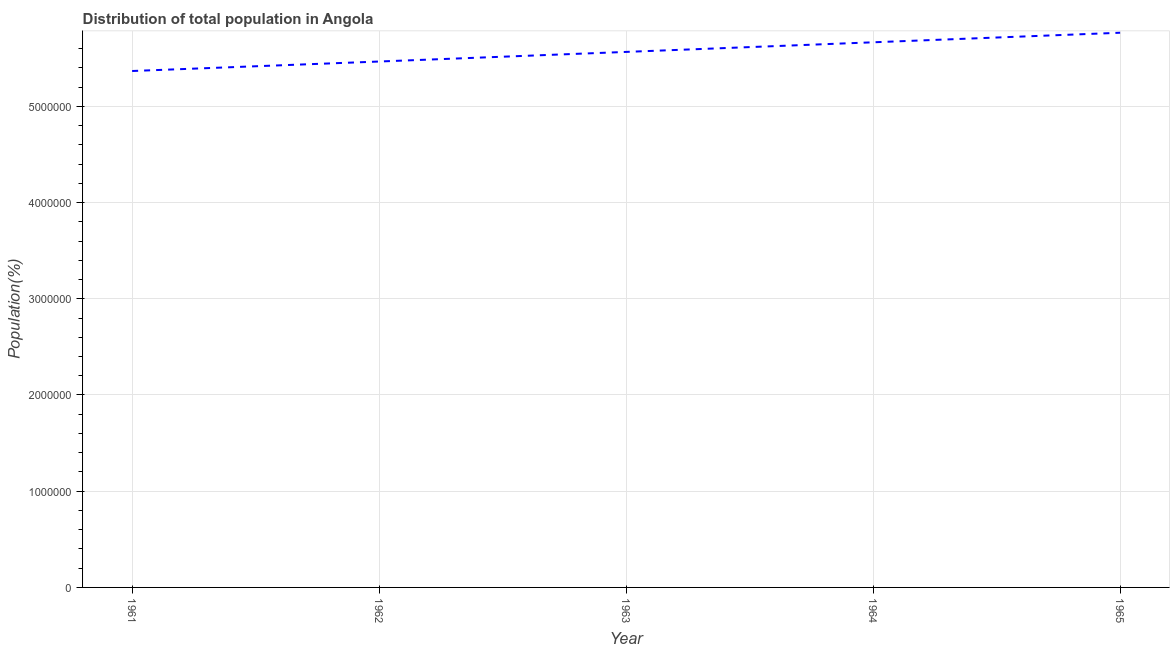What is the population in 1962?
Make the answer very short. 5.47e+06. Across all years, what is the maximum population?
Provide a succinct answer. 5.77e+06. Across all years, what is the minimum population?
Your answer should be compact. 5.37e+06. In which year was the population maximum?
Give a very brief answer. 1965. What is the sum of the population?
Your answer should be very brief. 2.78e+07. What is the difference between the population in 1961 and 1964?
Keep it short and to the point. -2.98e+05. What is the average population per year?
Give a very brief answer. 5.57e+06. What is the median population?
Your response must be concise. 5.57e+06. Do a majority of the years between 1961 and 1962 (inclusive) have population greater than 2200000 %?
Your answer should be very brief. Yes. What is the ratio of the population in 1961 to that in 1964?
Make the answer very short. 0.95. Is the population in 1962 less than that in 1964?
Your answer should be very brief. Yes. What is the difference between the highest and the second highest population?
Provide a succinct answer. 9.93e+04. What is the difference between the highest and the lowest population?
Give a very brief answer. 3.98e+05. In how many years, is the population greater than the average population taken over all years?
Offer a terse response. 2. Does the population monotonically increase over the years?
Provide a succinct answer. Yes. What is the difference between two consecutive major ticks on the Y-axis?
Give a very brief answer. 1.00e+06. Are the values on the major ticks of Y-axis written in scientific E-notation?
Provide a short and direct response. No. Does the graph contain any zero values?
Provide a succinct answer. No. What is the title of the graph?
Your answer should be very brief. Distribution of total population in Angola . What is the label or title of the X-axis?
Give a very brief answer. Year. What is the label or title of the Y-axis?
Your response must be concise. Population(%). What is the Population(%) of 1961?
Make the answer very short. 5.37e+06. What is the Population(%) of 1962?
Make the answer very short. 5.47e+06. What is the Population(%) in 1963?
Offer a terse response. 5.57e+06. What is the Population(%) of 1964?
Your response must be concise. 5.67e+06. What is the Population(%) in 1965?
Offer a terse response. 5.77e+06. What is the difference between the Population(%) in 1961 and 1962?
Offer a very short reply. -9.86e+04. What is the difference between the Population(%) in 1961 and 1963?
Provide a short and direct response. -1.99e+05. What is the difference between the Population(%) in 1961 and 1964?
Your answer should be very brief. -2.98e+05. What is the difference between the Population(%) in 1961 and 1965?
Provide a succinct answer. -3.98e+05. What is the difference between the Population(%) in 1962 and 1963?
Ensure brevity in your answer.  -9.99e+04. What is the difference between the Population(%) in 1962 and 1964?
Offer a very short reply. -2.00e+05. What is the difference between the Population(%) in 1962 and 1965?
Give a very brief answer. -2.99e+05. What is the difference between the Population(%) in 1963 and 1964?
Offer a very short reply. -9.99e+04. What is the difference between the Population(%) in 1963 and 1965?
Make the answer very short. -1.99e+05. What is the difference between the Population(%) in 1964 and 1965?
Give a very brief answer. -9.93e+04. What is the ratio of the Population(%) in 1961 to that in 1964?
Provide a succinct answer. 0.95. What is the ratio of the Population(%) in 1962 to that in 1963?
Ensure brevity in your answer.  0.98. What is the ratio of the Population(%) in 1962 to that in 1965?
Provide a short and direct response. 0.95. What is the ratio of the Population(%) in 1963 to that in 1964?
Ensure brevity in your answer.  0.98. What is the ratio of the Population(%) in 1964 to that in 1965?
Your answer should be compact. 0.98. 